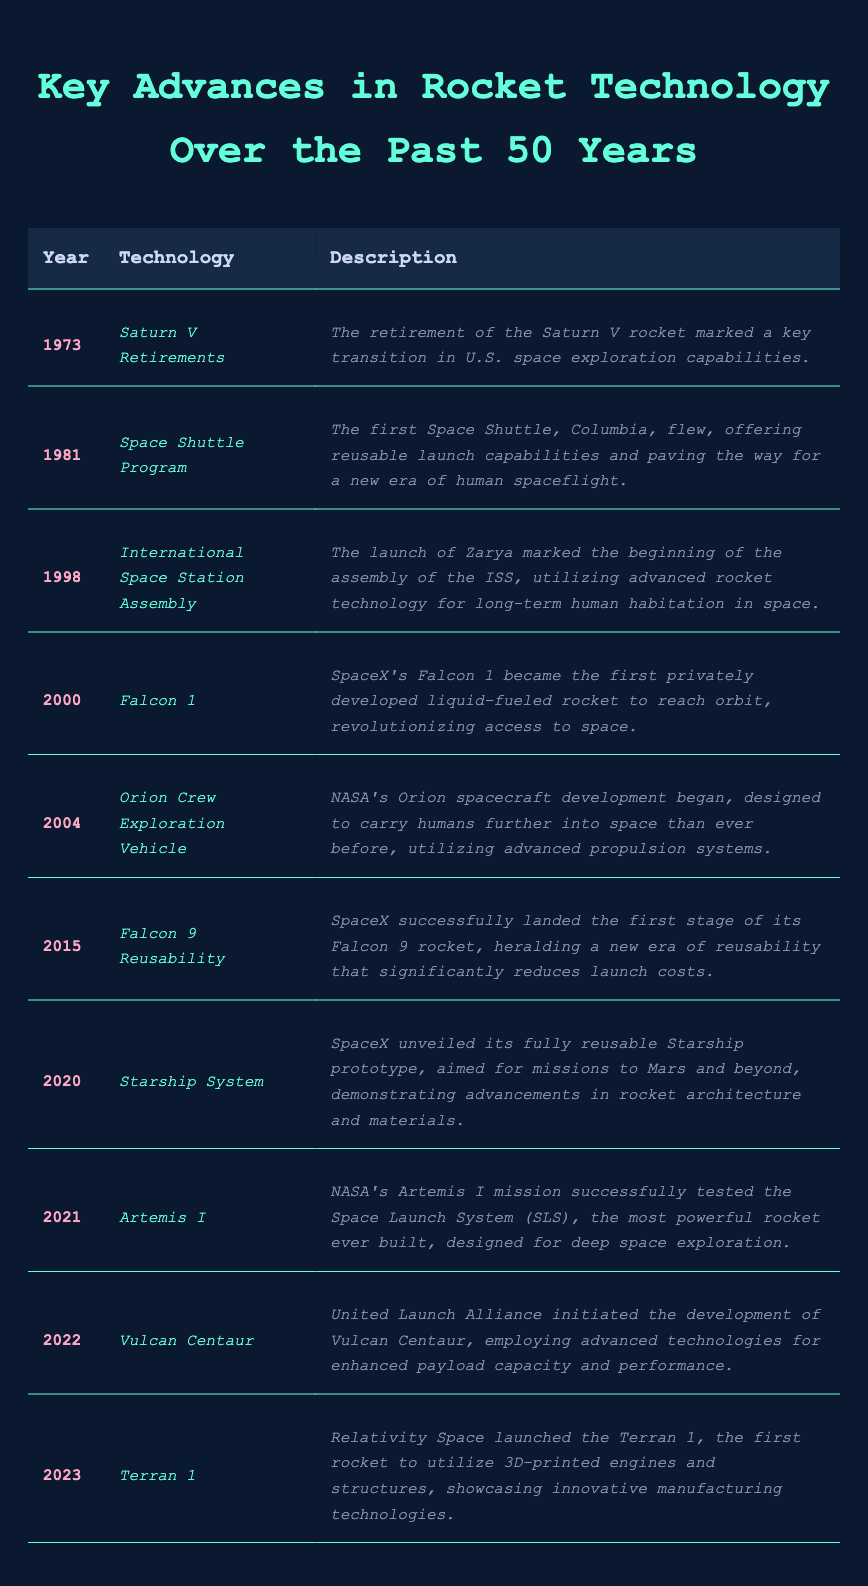What year did the Space Shuttle Program begin? The table indicates that the Space Shuttle Program started in 1981, as shown in the row with '1981' under the Year column.
Answer: 1981 Which rocket was launched in 2023? Referring to the table, the rocket launched in 2023 is the Terran 1, as specified in the corresponding row.
Answer: Terran 1 How many new technologies were introduced after the retirement of the Saturn V rocket? The Saturn V was retired in 1973. From 1981 to 2023, there are 8 technologies listed, which means 8 new technologies were introduced after the Saturn V retirements.
Answer: 8 Did the Falcon 9 Reusability change the cost dynamics of launching rockets? The description for Falcon 9 Reusability notes that it heralded a new era of reusability that significantly reduces launch costs. Therefore, it can be stated that yes, it did change cost dynamics.
Answer: Yes What was the first privately developed rocket to reach orbit, and in what year? According to the table, the first privately developed rocket to reach orbit was Falcon 1 in 2000.
Answer: Falcon 1, 2000 What is the significance of the Orion Crew Exploration Vehicle based on its year and description? The Orion was developed starting in 2004, designed to carry humans further into space than ever before with advanced propulsion systems. Its significance lies in its aim to expand human space exploration capabilities.
Answer: Designed for deep space exploration Which rocket technology developments occurred in odd-numbered years? The odd-numbered years listed in the table are 2001, 2015, 2021, and 2023. The technologies from those years are Falcon 1 (2000), Falcon 9 Reusability (2015), Artemis I (2021), and Terran 1 (2023). Therefore, the corresponding technologies are Falcon 1, Falcon 9 Reusability, Artemis I, and Terran 1.
Answer: Falcon 1, Falcon 9 Reusability, Artemis I, Terran 1 What advancements in rocket design were highlighted in the 2020 and 2023 entries of the table? In 2020, the Starship System was unveiled as a fully reusable prototype aimed at Mars missions, demonstrating advancements in rocket architecture. In 2023, the Terran 1 utilized 3D-printed engines and structures, showcasing innovative manufacturing technologies.
Answer: Starship and Terran 1 How many technologies were related to space habitation and exploration, as per the table? The relevant technologies include ISS Assembly (1998), Orion (2004), and Artemis I (2021), totaling three technologies related to human habitation and exploration.
Answer: 3 Which technology marked the beginning of the International Space Station assembly? The technology that marked the beginning of the ISS assembly is Zarya, which was launched in 1998, as described in that entry.
Answer: Zarya (1998) What's the technological innovation introduced with the launch of the Terran 1? According to the description in the table for 2023, the Terran 1 introduced 3D-printed engines and structures, showcasing innovative manufacturing technologies.
Answer: 3D-printed engines and structures 